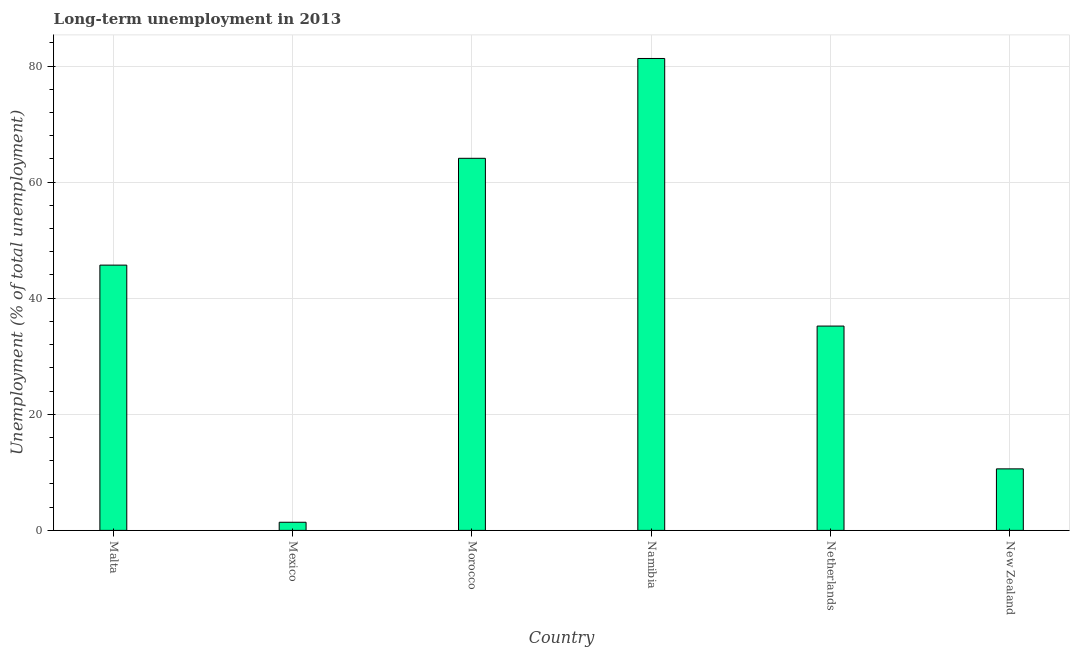Does the graph contain any zero values?
Give a very brief answer. No. What is the title of the graph?
Your answer should be compact. Long-term unemployment in 2013. What is the label or title of the X-axis?
Give a very brief answer. Country. What is the label or title of the Y-axis?
Provide a short and direct response. Unemployment (% of total unemployment). What is the long-term unemployment in Namibia?
Offer a very short reply. 81.3. Across all countries, what is the maximum long-term unemployment?
Your answer should be very brief. 81.3. Across all countries, what is the minimum long-term unemployment?
Your answer should be very brief. 1.4. In which country was the long-term unemployment maximum?
Offer a terse response. Namibia. What is the sum of the long-term unemployment?
Ensure brevity in your answer.  238.3. What is the difference between the long-term unemployment in Malta and New Zealand?
Your response must be concise. 35.1. What is the average long-term unemployment per country?
Make the answer very short. 39.72. What is the median long-term unemployment?
Keep it short and to the point. 40.45. In how many countries, is the long-term unemployment greater than 68 %?
Your answer should be very brief. 1. What is the ratio of the long-term unemployment in Malta to that in Namibia?
Your answer should be very brief. 0.56. What is the difference between the highest and the second highest long-term unemployment?
Provide a short and direct response. 17.2. What is the difference between the highest and the lowest long-term unemployment?
Make the answer very short. 79.9. How many bars are there?
Provide a short and direct response. 6. How many countries are there in the graph?
Provide a short and direct response. 6. What is the Unemployment (% of total unemployment) in Malta?
Give a very brief answer. 45.7. What is the Unemployment (% of total unemployment) in Mexico?
Offer a very short reply. 1.4. What is the Unemployment (% of total unemployment) of Morocco?
Your response must be concise. 64.1. What is the Unemployment (% of total unemployment) in Namibia?
Ensure brevity in your answer.  81.3. What is the Unemployment (% of total unemployment) of Netherlands?
Your answer should be compact. 35.2. What is the Unemployment (% of total unemployment) of New Zealand?
Keep it short and to the point. 10.6. What is the difference between the Unemployment (% of total unemployment) in Malta and Mexico?
Your response must be concise. 44.3. What is the difference between the Unemployment (% of total unemployment) in Malta and Morocco?
Your answer should be compact. -18.4. What is the difference between the Unemployment (% of total unemployment) in Malta and Namibia?
Give a very brief answer. -35.6. What is the difference between the Unemployment (% of total unemployment) in Malta and Netherlands?
Your response must be concise. 10.5. What is the difference between the Unemployment (% of total unemployment) in Malta and New Zealand?
Your response must be concise. 35.1. What is the difference between the Unemployment (% of total unemployment) in Mexico and Morocco?
Your answer should be very brief. -62.7. What is the difference between the Unemployment (% of total unemployment) in Mexico and Namibia?
Provide a succinct answer. -79.9. What is the difference between the Unemployment (% of total unemployment) in Mexico and Netherlands?
Offer a very short reply. -33.8. What is the difference between the Unemployment (% of total unemployment) in Mexico and New Zealand?
Offer a very short reply. -9.2. What is the difference between the Unemployment (% of total unemployment) in Morocco and Namibia?
Keep it short and to the point. -17.2. What is the difference between the Unemployment (% of total unemployment) in Morocco and Netherlands?
Give a very brief answer. 28.9. What is the difference between the Unemployment (% of total unemployment) in Morocco and New Zealand?
Your answer should be compact. 53.5. What is the difference between the Unemployment (% of total unemployment) in Namibia and Netherlands?
Ensure brevity in your answer.  46.1. What is the difference between the Unemployment (% of total unemployment) in Namibia and New Zealand?
Offer a very short reply. 70.7. What is the difference between the Unemployment (% of total unemployment) in Netherlands and New Zealand?
Ensure brevity in your answer.  24.6. What is the ratio of the Unemployment (% of total unemployment) in Malta to that in Mexico?
Ensure brevity in your answer.  32.64. What is the ratio of the Unemployment (% of total unemployment) in Malta to that in Morocco?
Provide a succinct answer. 0.71. What is the ratio of the Unemployment (% of total unemployment) in Malta to that in Namibia?
Give a very brief answer. 0.56. What is the ratio of the Unemployment (% of total unemployment) in Malta to that in Netherlands?
Provide a succinct answer. 1.3. What is the ratio of the Unemployment (% of total unemployment) in Malta to that in New Zealand?
Your response must be concise. 4.31. What is the ratio of the Unemployment (% of total unemployment) in Mexico to that in Morocco?
Provide a succinct answer. 0.02. What is the ratio of the Unemployment (% of total unemployment) in Mexico to that in Namibia?
Your response must be concise. 0.02. What is the ratio of the Unemployment (% of total unemployment) in Mexico to that in New Zealand?
Your response must be concise. 0.13. What is the ratio of the Unemployment (% of total unemployment) in Morocco to that in Namibia?
Offer a very short reply. 0.79. What is the ratio of the Unemployment (% of total unemployment) in Morocco to that in Netherlands?
Your response must be concise. 1.82. What is the ratio of the Unemployment (% of total unemployment) in Morocco to that in New Zealand?
Provide a short and direct response. 6.05. What is the ratio of the Unemployment (% of total unemployment) in Namibia to that in Netherlands?
Your answer should be very brief. 2.31. What is the ratio of the Unemployment (% of total unemployment) in Namibia to that in New Zealand?
Keep it short and to the point. 7.67. What is the ratio of the Unemployment (% of total unemployment) in Netherlands to that in New Zealand?
Give a very brief answer. 3.32. 